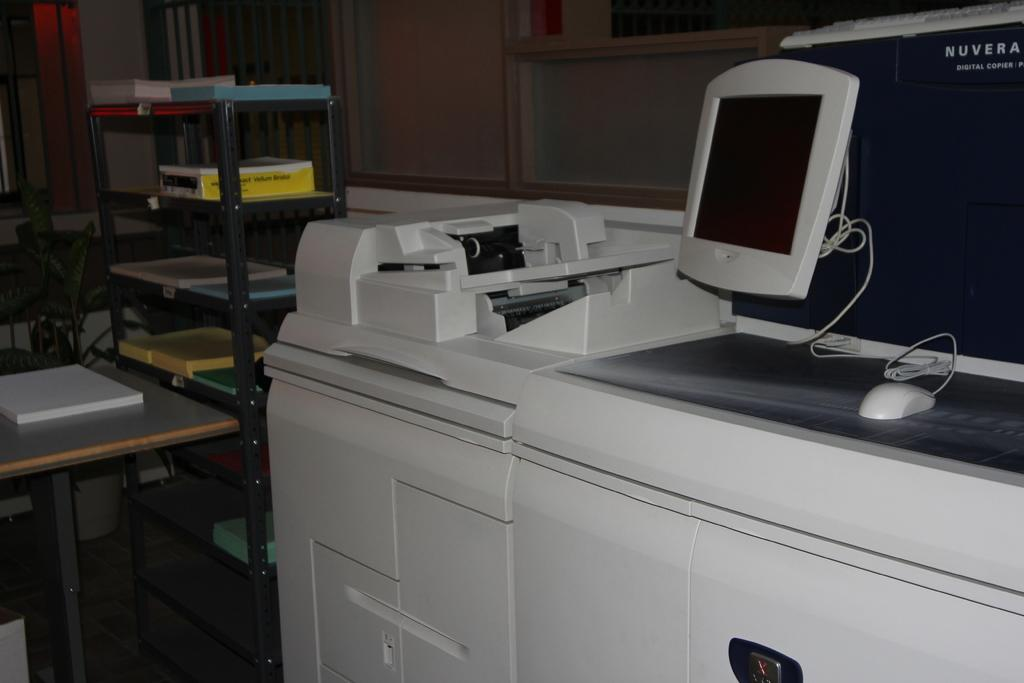<image>
Offer a succinct explanation of the picture presented. Nuvera digital copier with two computer screens on top of it. 